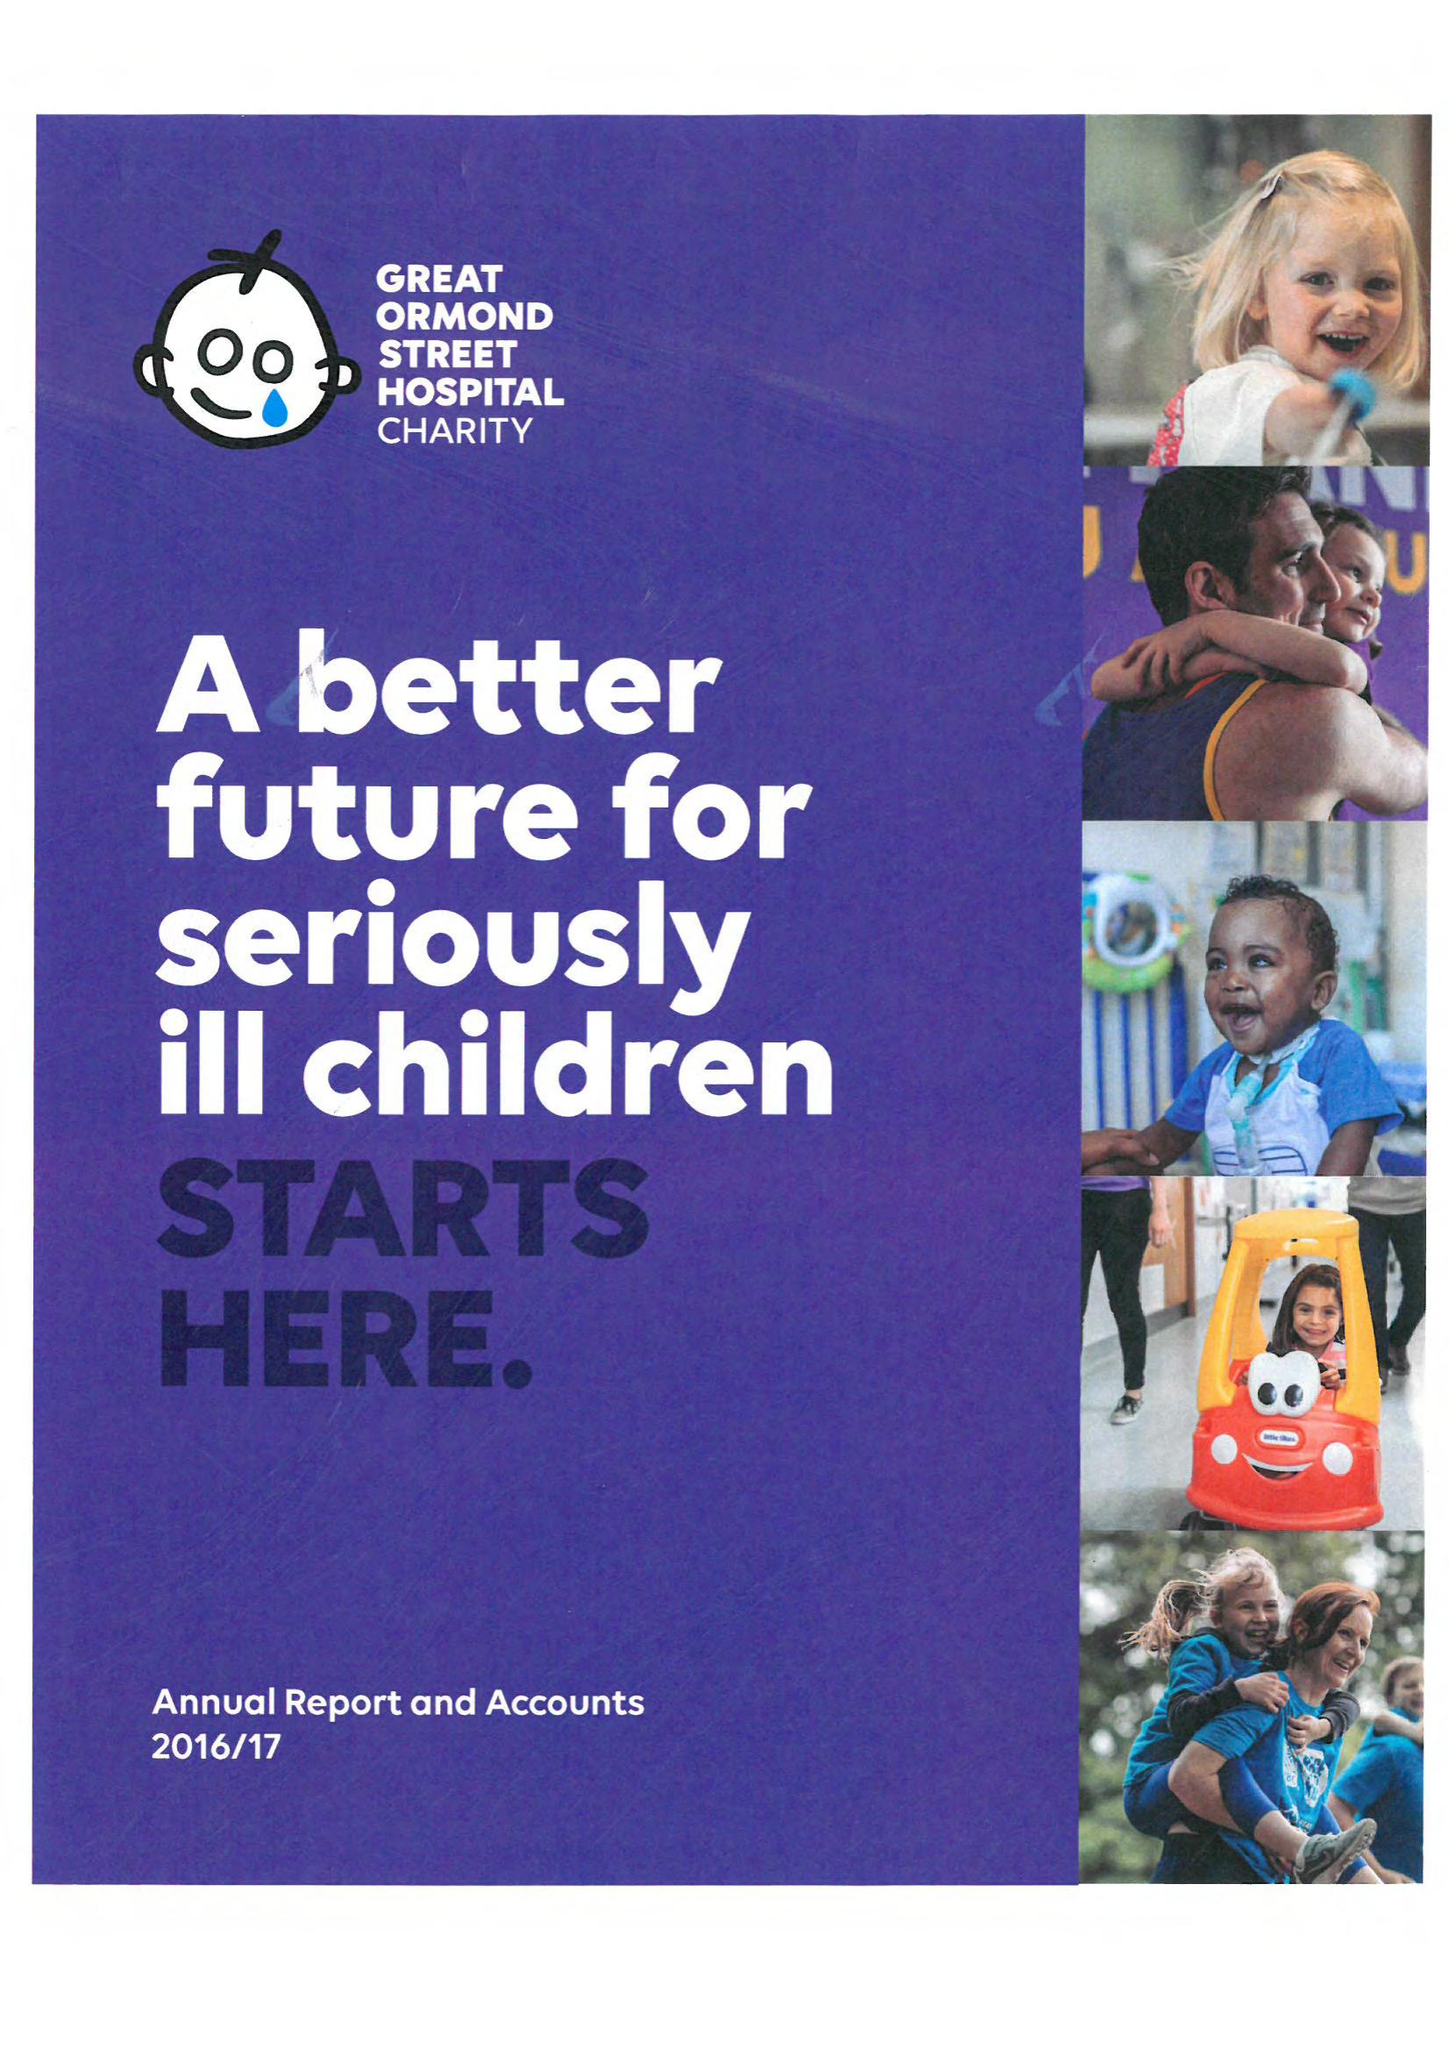What is the value for the address__post_town?
Answer the question using a single word or phrase. LONDON 